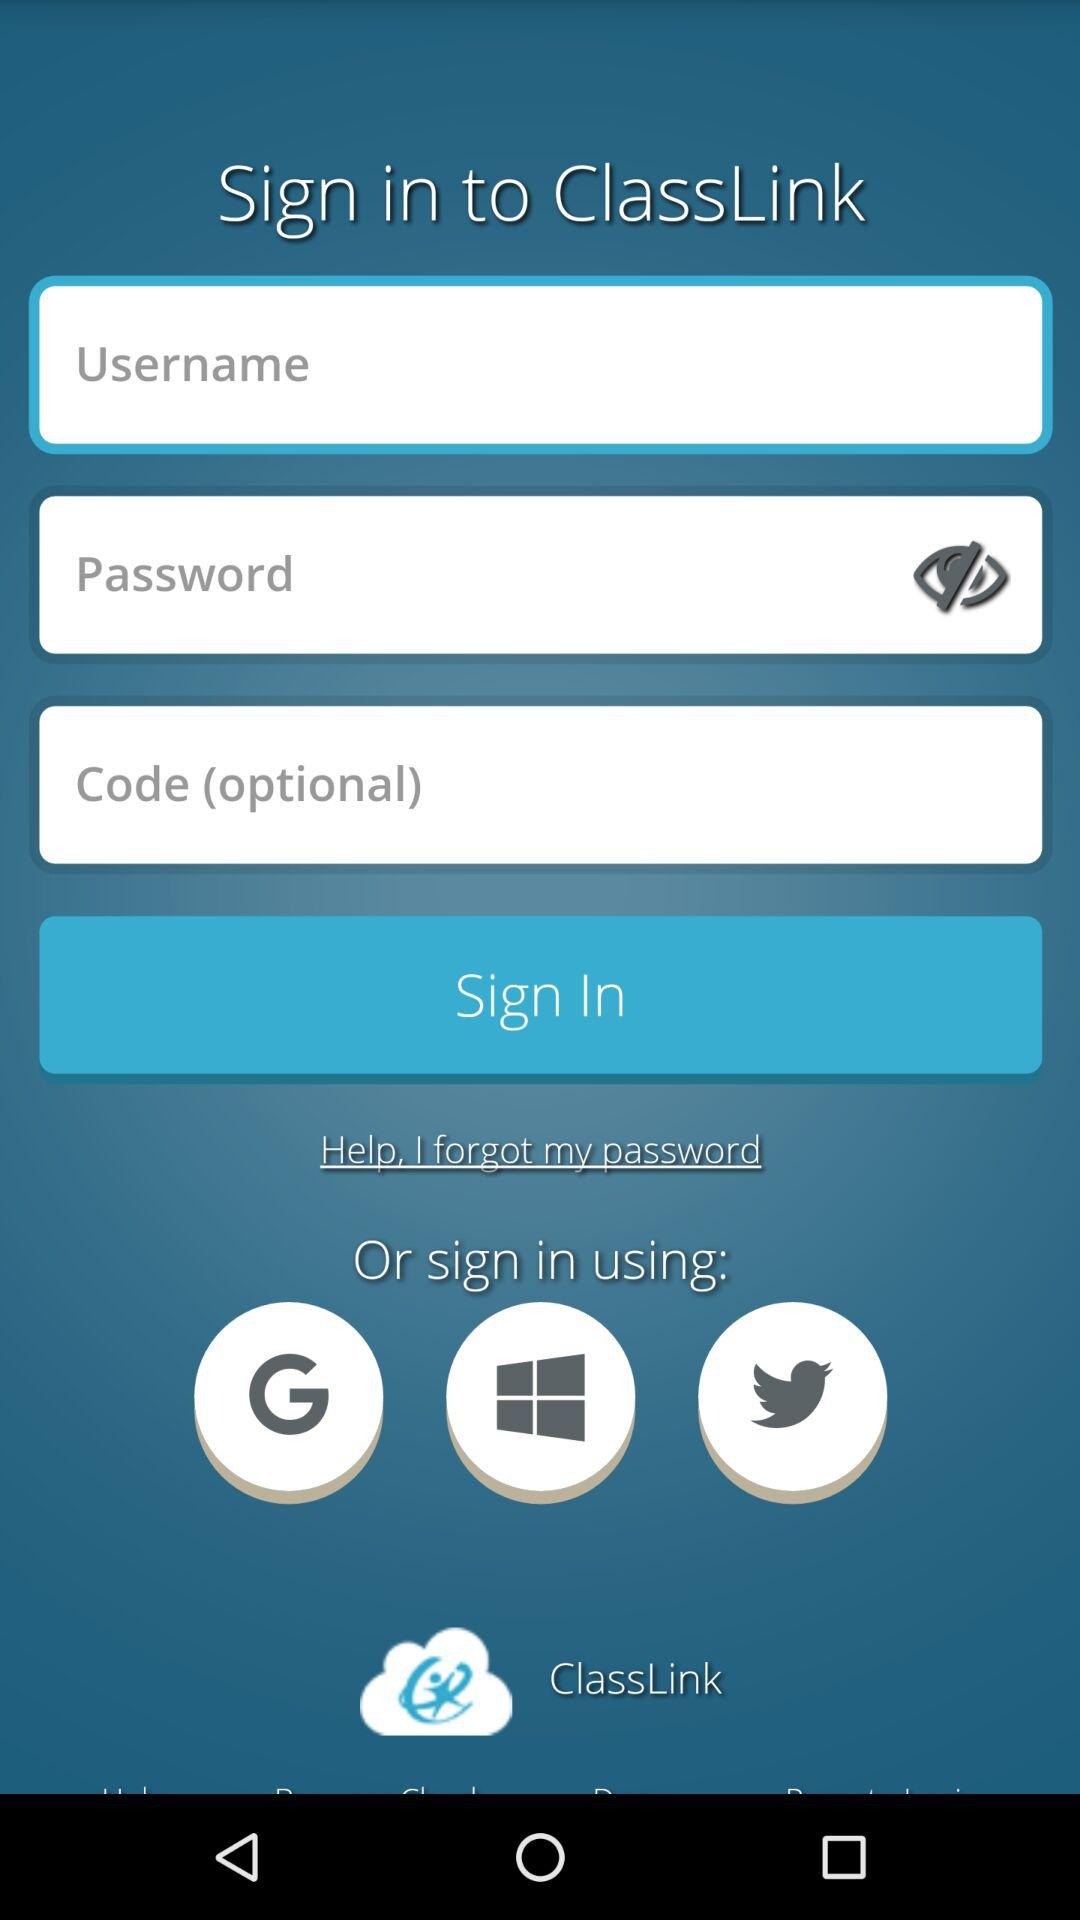How many text inputs are there for logging in?
Answer the question using a single word or phrase. 3 